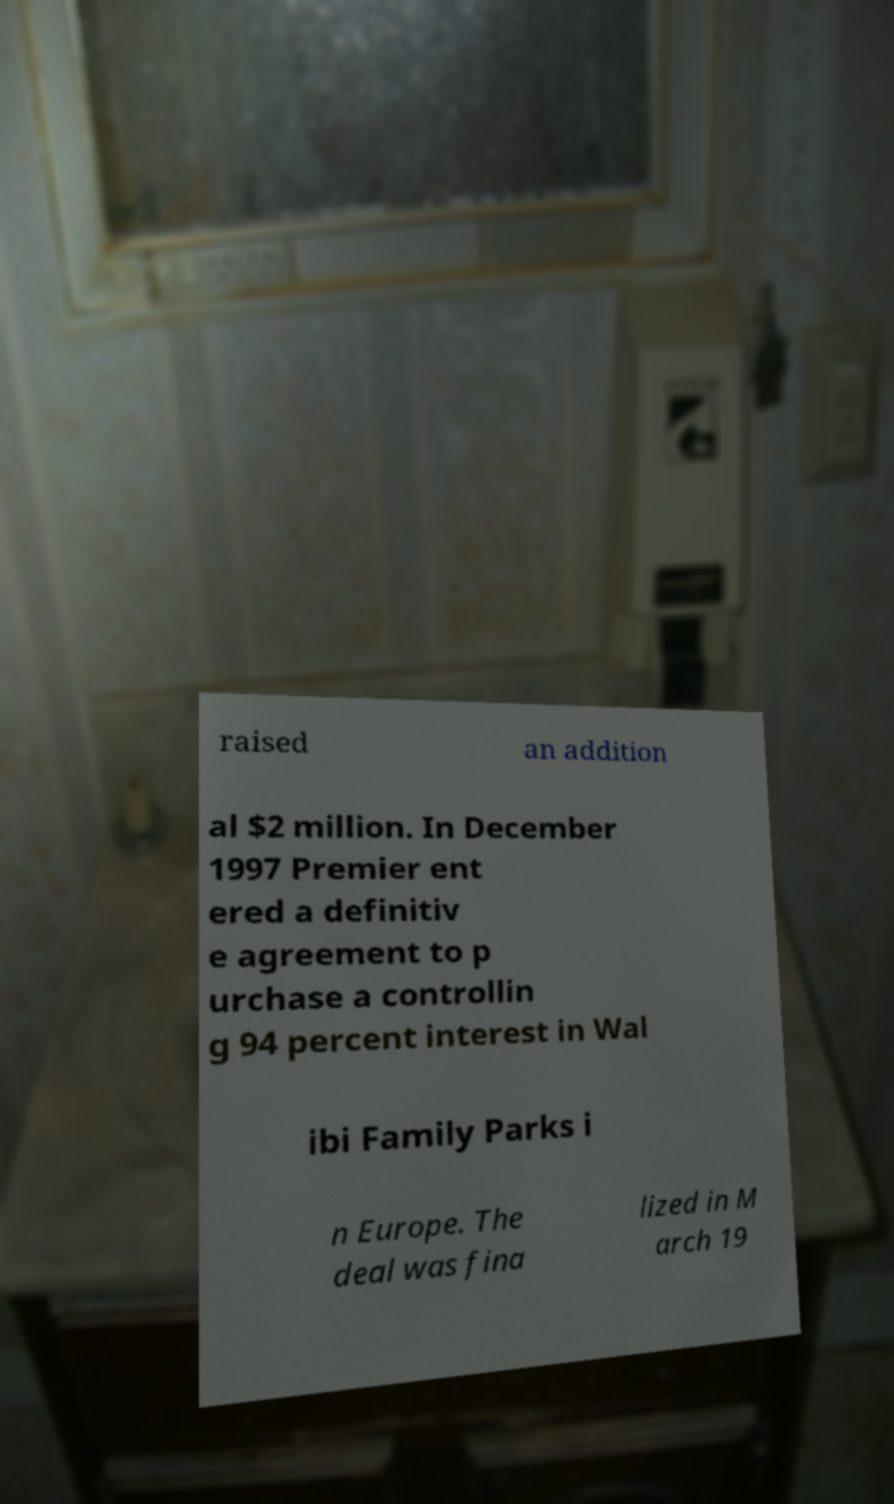Could you extract and type out the text from this image? raised an addition al $2 million. In December 1997 Premier ent ered a definitiv e agreement to p urchase a controllin g 94 percent interest in Wal ibi Family Parks i n Europe. The deal was fina lized in M arch 19 